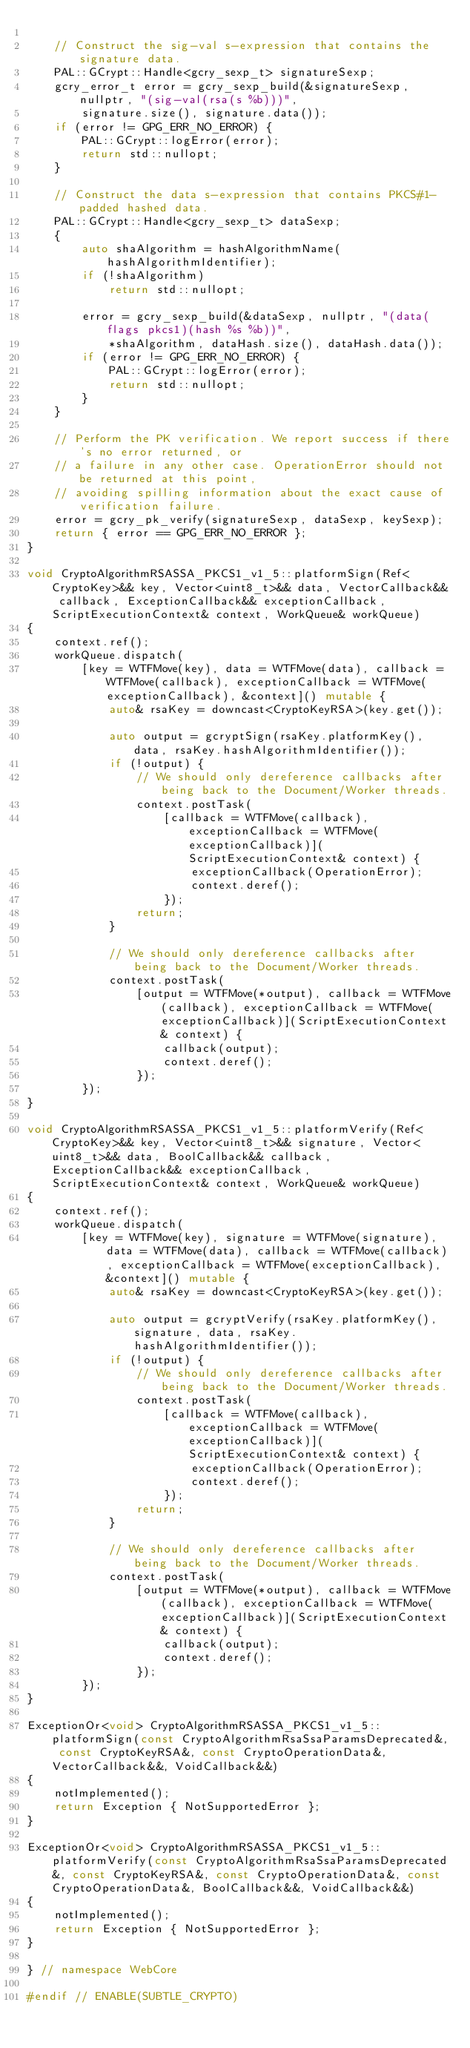<code> <loc_0><loc_0><loc_500><loc_500><_C++_>
    // Construct the sig-val s-expression that contains the signature data.
    PAL::GCrypt::Handle<gcry_sexp_t> signatureSexp;
    gcry_error_t error = gcry_sexp_build(&signatureSexp, nullptr, "(sig-val(rsa(s %b)))",
        signature.size(), signature.data());
    if (error != GPG_ERR_NO_ERROR) {
        PAL::GCrypt::logError(error);
        return std::nullopt;
    }

    // Construct the data s-expression that contains PKCS#1-padded hashed data.
    PAL::GCrypt::Handle<gcry_sexp_t> dataSexp;
    {
        auto shaAlgorithm = hashAlgorithmName(hashAlgorithmIdentifier);
        if (!shaAlgorithm)
            return std::nullopt;

        error = gcry_sexp_build(&dataSexp, nullptr, "(data(flags pkcs1)(hash %s %b))",
            *shaAlgorithm, dataHash.size(), dataHash.data());
        if (error != GPG_ERR_NO_ERROR) {
            PAL::GCrypt::logError(error);
            return std::nullopt;
        }
    }

    // Perform the PK verification. We report success if there's no error returned, or
    // a failure in any other case. OperationError should not be returned at this point,
    // avoiding spilling information about the exact cause of verification failure.
    error = gcry_pk_verify(signatureSexp, dataSexp, keySexp);
    return { error == GPG_ERR_NO_ERROR };
}

void CryptoAlgorithmRSASSA_PKCS1_v1_5::platformSign(Ref<CryptoKey>&& key, Vector<uint8_t>&& data, VectorCallback&& callback, ExceptionCallback&& exceptionCallback, ScriptExecutionContext& context, WorkQueue& workQueue)
{
    context.ref();
    workQueue.dispatch(
        [key = WTFMove(key), data = WTFMove(data), callback = WTFMove(callback), exceptionCallback = WTFMove(exceptionCallback), &context]() mutable {
            auto& rsaKey = downcast<CryptoKeyRSA>(key.get());

            auto output = gcryptSign(rsaKey.platformKey(), data, rsaKey.hashAlgorithmIdentifier());
            if (!output) {
                // We should only dereference callbacks after being back to the Document/Worker threads.
                context.postTask(
                    [callback = WTFMove(callback), exceptionCallback = WTFMove(exceptionCallback)](ScriptExecutionContext& context) {
                        exceptionCallback(OperationError);
                        context.deref();
                    });
                return;
            }

            // We should only dereference callbacks after being back to the Document/Worker threads.
            context.postTask(
                [output = WTFMove(*output), callback = WTFMove(callback), exceptionCallback = WTFMove(exceptionCallback)](ScriptExecutionContext& context) {
                    callback(output);
                    context.deref();
                });
        });
}

void CryptoAlgorithmRSASSA_PKCS1_v1_5::platformVerify(Ref<CryptoKey>&& key, Vector<uint8_t>&& signature, Vector<uint8_t>&& data, BoolCallback&& callback, ExceptionCallback&& exceptionCallback, ScriptExecutionContext& context, WorkQueue& workQueue)
{
    context.ref();
    workQueue.dispatch(
        [key = WTFMove(key), signature = WTFMove(signature), data = WTFMove(data), callback = WTFMove(callback), exceptionCallback = WTFMove(exceptionCallback), &context]() mutable {
            auto& rsaKey = downcast<CryptoKeyRSA>(key.get());

            auto output = gcryptVerify(rsaKey.platformKey(), signature, data, rsaKey.hashAlgorithmIdentifier());
            if (!output) {
                // We should only dereference callbacks after being back to the Document/Worker threads.
                context.postTask(
                    [callback = WTFMove(callback), exceptionCallback = WTFMove(exceptionCallback)](ScriptExecutionContext& context) {
                        exceptionCallback(OperationError);
                        context.deref();
                    });
                return;
            }

            // We should only dereference callbacks after being back to the Document/Worker threads.
            context.postTask(
                [output = WTFMove(*output), callback = WTFMove(callback), exceptionCallback = WTFMove(exceptionCallback)](ScriptExecutionContext& context) {
                    callback(output);
                    context.deref();
                });
        });
}

ExceptionOr<void> CryptoAlgorithmRSASSA_PKCS1_v1_5::platformSign(const CryptoAlgorithmRsaSsaParamsDeprecated&, const CryptoKeyRSA&, const CryptoOperationData&, VectorCallback&&, VoidCallback&&)
{
    notImplemented();
    return Exception { NotSupportedError };
}

ExceptionOr<void> CryptoAlgorithmRSASSA_PKCS1_v1_5::platformVerify(const CryptoAlgorithmRsaSsaParamsDeprecated&, const CryptoKeyRSA&, const CryptoOperationData&, const CryptoOperationData&, BoolCallback&&, VoidCallback&&)
{
    notImplemented();
    return Exception { NotSupportedError };
}

} // namespace WebCore

#endif // ENABLE(SUBTLE_CRYPTO)
</code> 